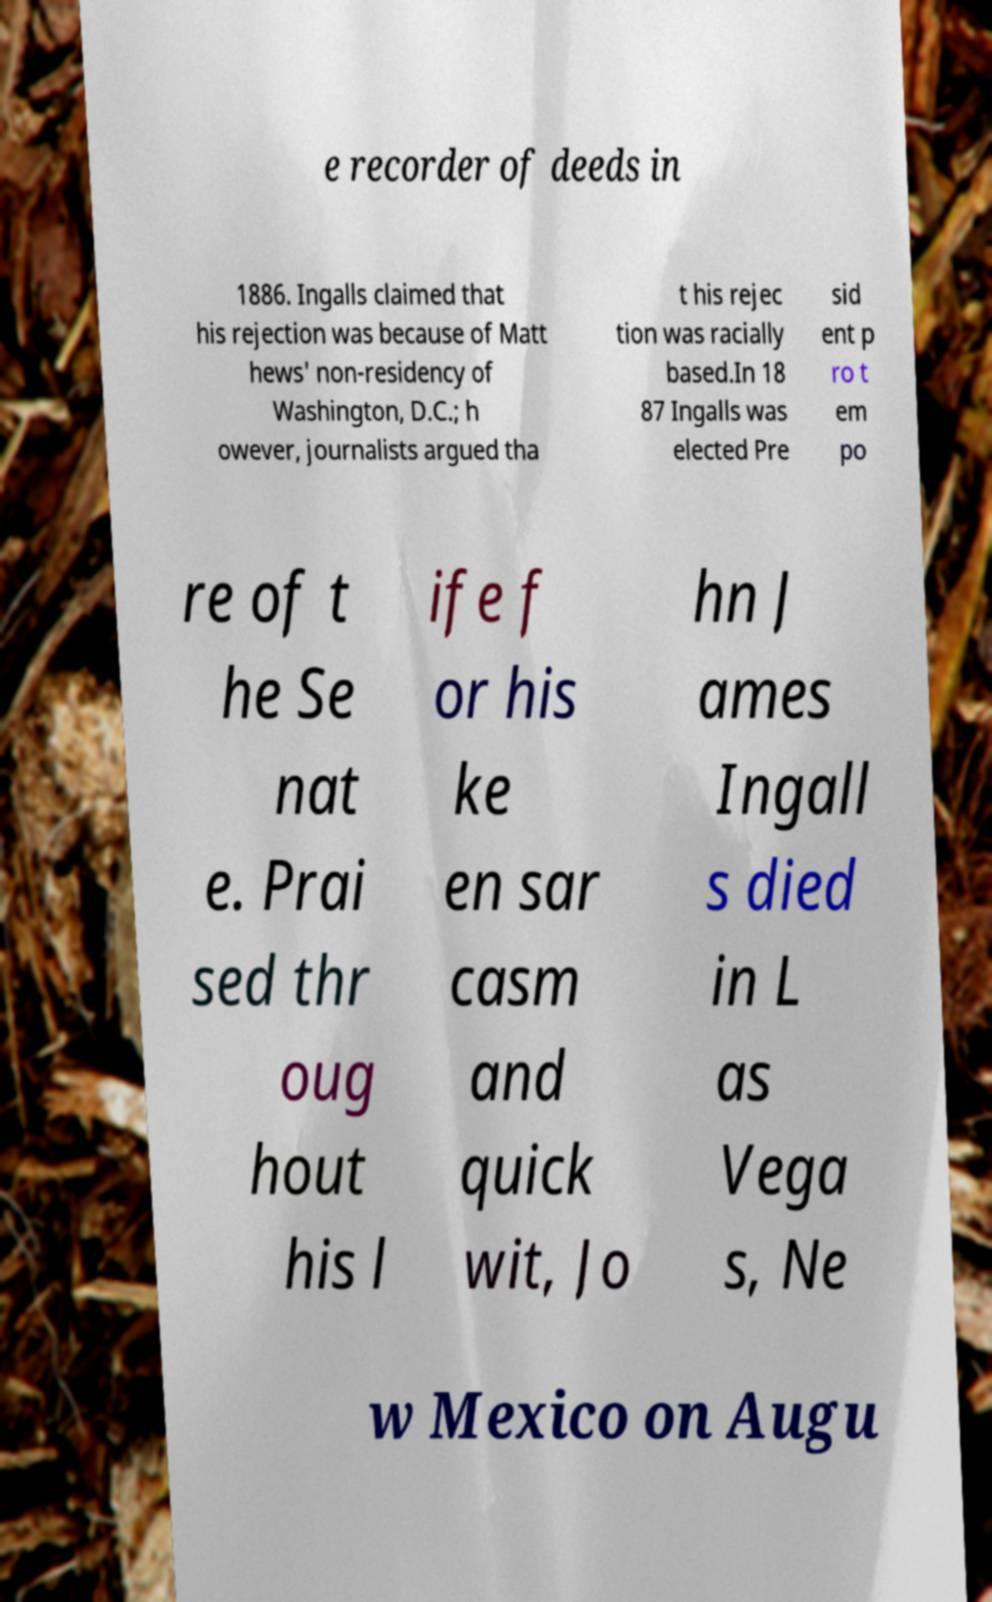I need the written content from this picture converted into text. Can you do that? e recorder of deeds in 1886. Ingalls claimed that his rejection was because of Matt hews' non-residency of Washington, D.C.; h owever, journalists argued tha t his rejec tion was racially based.In 18 87 Ingalls was elected Pre sid ent p ro t em po re of t he Se nat e. Prai sed thr oug hout his l ife f or his ke en sar casm and quick wit, Jo hn J ames Ingall s died in L as Vega s, Ne w Mexico on Augu 